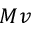Convert formula to latex. <formula><loc_0><loc_0><loc_500><loc_500>M v</formula> 